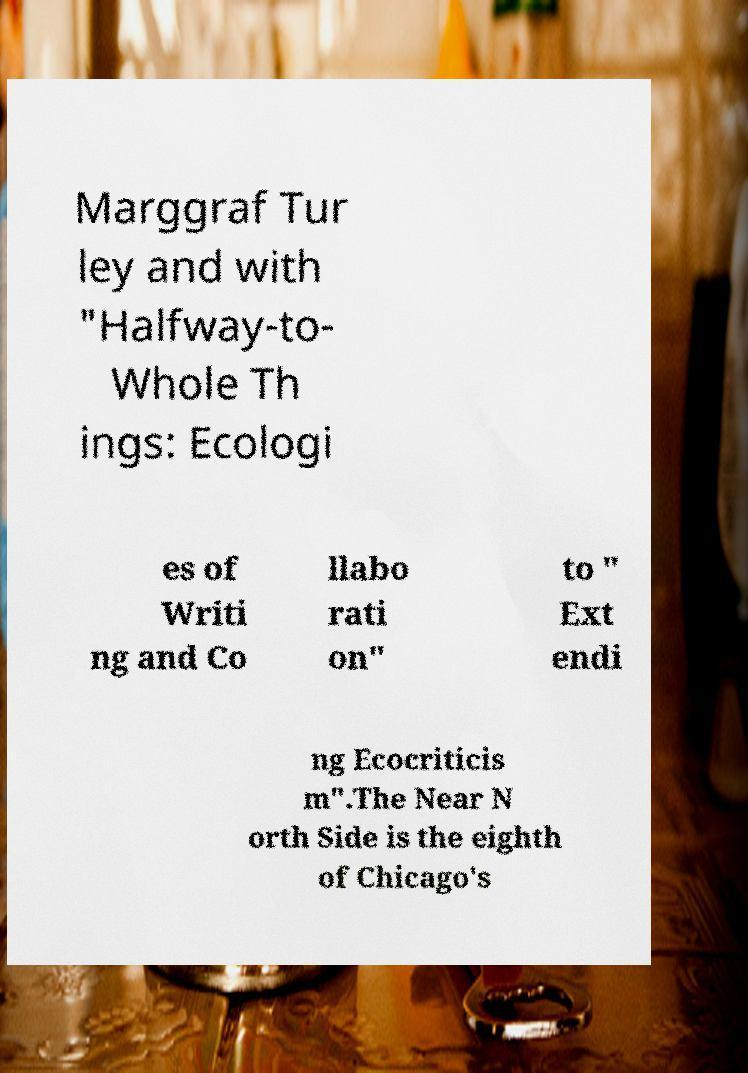There's text embedded in this image that I need extracted. Can you transcribe it verbatim? Marggraf Tur ley and with "Halfway-to- Whole Th ings: Ecologi es of Writi ng and Co llabo rati on" to " Ext endi ng Ecocriticis m".The Near N orth Side is the eighth of Chicago's 